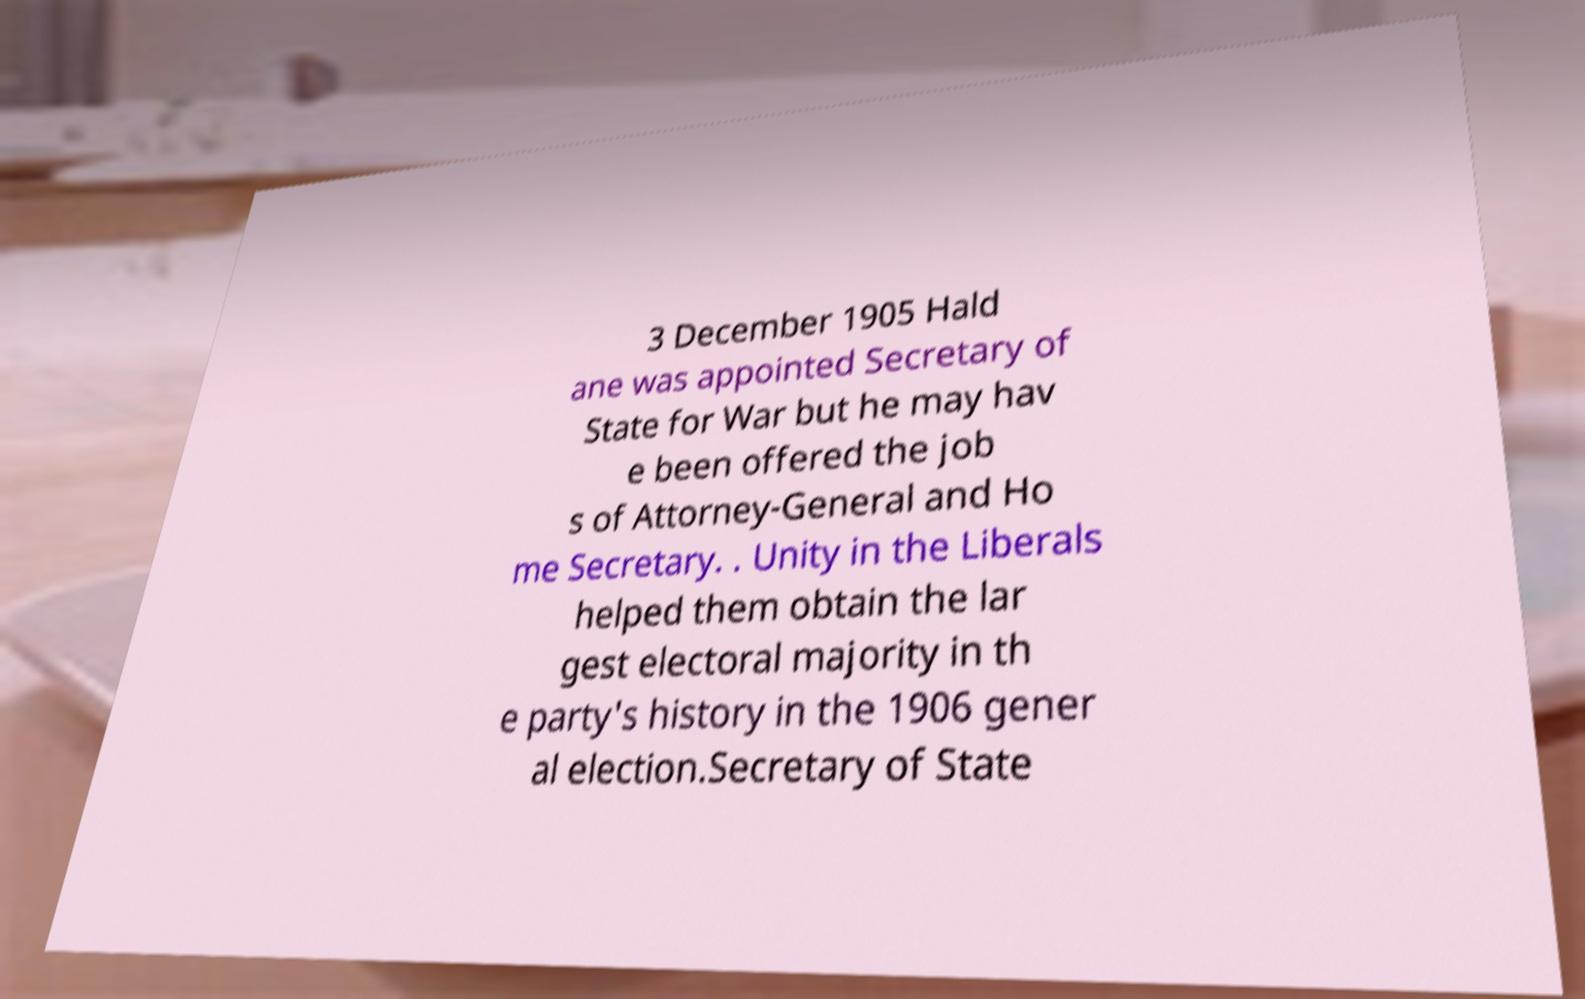Please identify and transcribe the text found in this image. 3 December 1905 Hald ane was appointed Secretary of State for War but he may hav e been offered the job s of Attorney-General and Ho me Secretary. . Unity in the Liberals helped them obtain the lar gest electoral majority in th e party's history in the 1906 gener al election.Secretary of State 